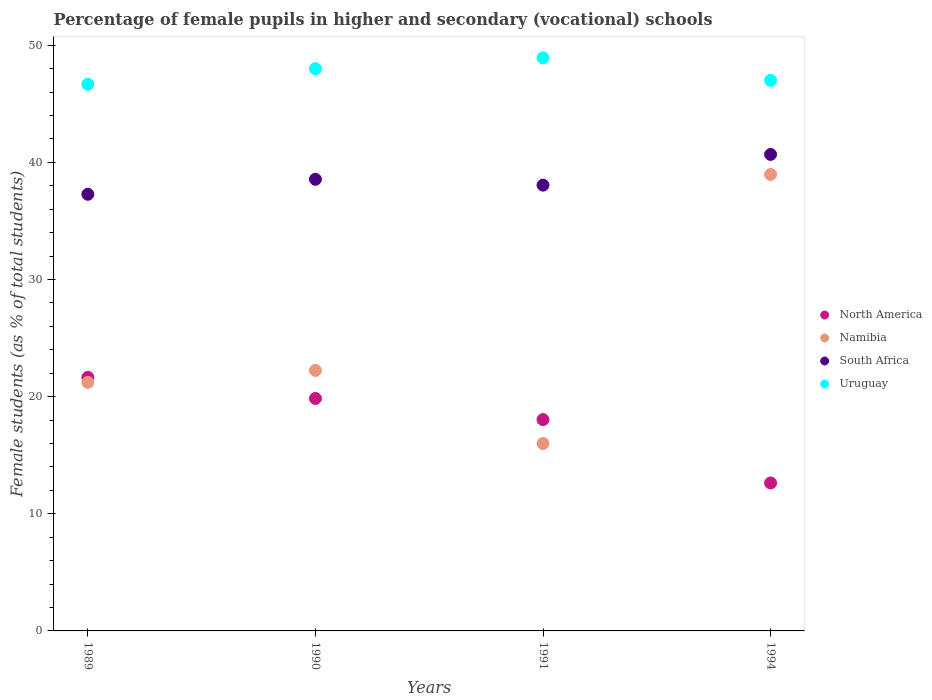Is the number of dotlines equal to the number of legend labels?
Offer a very short reply. Yes. What is the percentage of female pupils in higher and secondary schools in North America in 1994?
Make the answer very short. 12.63. Across all years, what is the maximum percentage of female pupils in higher and secondary schools in Namibia?
Your response must be concise. 38.97. Across all years, what is the minimum percentage of female pupils in higher and secondary schools in North America?
Your answer should be very brief. 12.63. In which year was the percentage of female pupils in higher and secondary schools in Namibia maximum?
Keep it short and to the point. 1994. In which year was the percentage of female pupils in higher and secondary schools in South Africa minimum?
Keep it short and to the point. 1989. What is the total percentage of female pupils in higher and secondary schools in North America in the graph?
Your answer should be very brief. 72.16. What is the difference between the percentage of female pupils in higher and secondary schools in North America in 1989 and that in 1991?
Offer a terse response. 3.61. What is the difference between the percentage of female pupils in higher and secondary schools in Uruguay in 1991 and the percentage of female pupils in higher and secondary schools in North America in 1990?
Offer a terse response. 29.08. What is the average percentage of female pupils in higher and secondary schools in North America per year?
Give a very brief answer. 18.04. In the year 1989, what is the difference between the percentage of female pupils in higher and secondary schools in Uruguay and percentage of female pupils in higher and secondary schools in Namibia?
Your answer should be compact. 25.45. In how many years, is the percentage of female pupils in higher and secondary schools in South Africa greater than 4 %?
Offer a terse response. 4. What is the ratio of the percentage of female pupils in higher and secondary schools in South Africa in 1990 to that in 1991?
Make the answer very short. 1.01. Is the percentage of female pupils in higher and secondary schools in Uruguay in 1991 less than that in 1994?
Provide a short and direct response. No. Is the difference between the percentage of female pupils in higher and secondary schools in Uruguay in 1989 and 1991 greater than the difference between the percentage of female pupils in higher and secondary schools in Namibia in 1989 and 1991?
Keep it short and to the point. No. What is the difference between the highest and the second highest percentage of female pupils in higher and secondary schools in Namibia?
Keep it short and to the point. 16.73. What is the difference between the highest and the lowest percentage of female pupils in higher and secondary schools in South Africa?
Your response must be concise. 3.4. Is it the case that in every year, the sum of the percentage of female pupils in higher and secondary schools in Uruguay and percentage of female pupils in higher and secondary schools in North America  is greater than the sum of percentage of female pupils in higher and secondary schools in South Africa and percentage of female pupils in higher and secondary schools in Namibia?
Give a very brief answer. Yes. Is the percentage of female pupils in higher and secondary schools in North America strictly greater than the percentage of female pupils in higher and secondary schools in Uruguay over the years?
Keep it short and to the point. No. Is the percentage of female pupils in higher and secondary schools in South Africa strictly less than the percentage of female pupils in higher and secondary schools in North America over the years?
Your answer should be very brief. No. How many dotlines are there?
Offer a very short reply. 4. Does the graph contain grids?
Offer a very short reply. No. How many legend labels are there?
Offer a terse response. 4. What is the title of the graph?
Offer a terse response. Percentage of female pupils in higher and secondary (vocational) schools. Does "New Caledonia" appear as one of the legend labels in the graph?
Your answer should be compact. No. What is the label or title of the Y-axis?
Ensure brevity in your answer.  Female students (as % of total students). What is the Female students (as % of total students) of North America in 1989?
Your answer should be very brief. 21.65. What is the Female students (as % of total students) in Namibia in 1989?
Your answer should be compact. 21.22. What is the Female students (as % of total students) in South Africa in 1989?
Offer a terse response. 37.28. What is the Female students (as % of total students) of Uruguay in 1989?
Provide a short and direct response. 46.67. What is the Female students (as % of total students) in North America in 1990?
Your answer should be very brief. 19.84. What is the Female students (as % of total students) in Namibia in 1990?
Make the answer very short. 22.24. What is the Female students (as % of total students) of South Africa in 1990?
Make the answer very short. 38.56. What is the Female students (as % of total students) of Uruguay in 1990?
Make the answer very short. 48. What is the Female students (as % of total students) of North America in 1991?
Keep it short and to the point. 18.04. What is the Female students (as % of total students) in Namibia in 1991?
Offer a terse response. 16. What is the Female students (as % of total students) of South Africa in 1991?
Ensure brevity in your answer.  38.06. What is the Female students (as % of total students) of Uruguay in 1991?
Provide a short and direct response. 48.93. What is the Female students (as % of total students) in North America in 1994?
Offer a terse response. 12.63. What is the Female students (as % of total students) of Namibia in 1994?
Offer a terse response. 38.97. What is the Female students (as % of total students) of South Africa in 1994?
Ensure brevity in your answer.  40.68. What is the Female students (as % of total students) in Uruguay in 1994?
Make the answer very short. 47.01. Across all years, what is the maximum Female students (as % of total students) of North America?
Provide a short and direct response. 21.65. Across all years, what is the maximum Female students (as % of total students) in Namibia?
Provide a succinct answer. 38.97. Across all years, what is the maximum Female students (as % of total students) in South Africa?
Keep it short and to the point. 40.68. Across all years, what is the maximum Female students (as % of total students) of Uruguay?
Offer a terse response. 48.93. Across all years, what is the minimum Female students (as % of total students) in North America?
Offer a terse response. 12.63. Across all years, what is the minimum Female students (as % of total students) of South Africa?
Your answer should be very brief. 37.28. Across all years, what is the minimum Female students (as % of total students) in Uruguay?
Keep it short and to the point. 46.67. What is the total Female students (as % of total students) in North America in the graph?
Your answer should be compact. 72.16. What is the total Female students (as % of total students) of Namibia in the graph?
Offer a very short reply. 98.43. What is the total Female students (as % of total students) in South Africa in the graph?
Your response must be concise. 154.57. What is the total Female students (as % of total students) of Uruguay in the graph?
Offer a terse response. 190.6. What is the difference between the Female students (as % of total students) of North America in 1989 and that in 1990?
Keep it short and to the point. 1.8. What is the difference between the Female students (as % of total students) of Namibia in 1989 and that in 1990?
Offer a terse response. -1.02. What is the difference between the Female students (as % of total students) in South Africa in 1989 and that in 1990?
Ensure brevity in your answer.  -1.28. What is the difference between the Female students (as % of total students) in Uruguay in 1989 and that in 1990?
Your response must be concise. -1.33. What is the difference between the Female students (as % of total students) of North America in 1989 and that in 1991?
Make the answer very short. 3.61. What is the difference between the Female students (as % of total students) of Namibia in 1989 and that in 1991?
Give a very brief answer. 5.22. What is the difference between the Female students (as % of total students) of South Africa in 1989 and that in 1991?
Your answer should be compact. -0.78. What is the difference between the Female students (as % of total students) of Uruguay in 1989 and that in 1991?
Ensure brevity in your answer.  -2.26. What is the difference between the Female students (as % of total students) in North America in 1989 and that in 1994?
Keep it short and to the point. 9.02. What is the difference between the Female students (as % of total students) of Namibia in 1989 and that in 1994?
Give a very brief answer. -17.75. What is the difference between the Female students (as % of total students) in South Africa in 1989 and that in 1994?
Offer a very short reply. -3.4. What is the difference between the Female students (as % of total students) in Uruguay in 1989 and that in 1994?
Keep it short and to the point. -0.34. What is the difference between the Female students (as % of total students) of North America in 1990 and that in 1991?
Provide a short and direct response. 1.8. What is the difference between the Female students (as % of total students) in Namibia in 1990 and that in 1991?
Offer a very short reply. 6.24. What is the difference between the Female students (as % of total students) in South Africa in 1990 and that in 1991?
Ensure brevity in your answer.  0.5. What is the difference between the Female students (as % of total students) in Uruguay in 1990 and that in 1991?
Offer a terse response. -0.93. What is the difference between the Female students (as % of total students) of North America in 1990 and that in 1994?
Your answer should be compact. 7.22. What is the difference between the Female students (as % of total students) of Namibia in 1990 and that in 1994?
Make the answer very short. -16.73. What is the difference between the Female students (as % of total students) in South Africa in 1990 and that in 1994?
Ensure brevity in your answer.  -2.13. What is the difference between the Female students (as % of total students) in North America in 1991 and that in 1994?
Keep it short and to the point. 5.41. What is the difference between the Female students (as % of total students) in Namibia in 1991 and that in 1994?
Give a very brief answer. -22.97. What is the difference between the Female students (as % of total students) in South Africa in 1991 and that in 1994?
Your answer should be compact. -2.62. What is the difference between the Female students (as % of total students) in Uruguay in 1991 and that in 1994?
Offer a very short reply. 1.92. What is the difference between the Female students (as % of total students) in North America in 1989 and the Female students (as % of total students) in Namibia in 1990?
Offer a very short reply. -0.59. What is the difference between the Female students (as % of total students) of North America in 1989 and the Female students (as % of total students) of South Africa in 1990?
Make the answer very short. -16.91. What is the difference between the Female students (as % of total students) of North America in 1989 and the Female students (as % of total students) of Uruguay in 1990?
Ensure brevity in your answer.  -26.35. What is the difference between the Female students (as % of total students) in Namibia in 1989 and the Female students (as % of total students) in South Africa in 1990?
Provide a short and direct response. -17.34. What is the difference between the Female students (as % of total students) of Namibia in 1989 and the Female students (as % of total students) of Uruguay in 1990?
Make the answer very short. -26.78. What is the difference between the Female students (as % of total students) in South Africa in 1989 and the Female students (as % of total students) in Uruguay in 1990?
Your answer should be very brief. -10.72. What is the difference between the Female students (as % of total students) in North America in 1989 and the Female students (as % of total students) in Namibia in 1991?
Offer a terse response. 5.65. What is the difference between the Female students (as % of total students) in North America in 1989 and the Female students (as % of total students) in South Africa in 1991?
Provide a succinct answer. -16.41. What is the difference between the Female students (as % of total students) in North America in 1989 and the Female students (as % of total students) in Uruguay in 1991?
Give a very brief answer. -27.28. What is the difference between the Female students (as % of total students) of Namibia in 1989 and the Female students (as % of total students) of South Africa in 1991?
Your answer should be compact. -16.84. What is the difference between the Female students (as % of total students) in Namibia in 1989 and the Female students (as % of total students) in Uruguay in 1991?
Your answer should be very brief. -27.71. What is the difference between the Female students (as % of total students) in South Africa in 1989 and the Female students (as % of total students) in Uruguay in 1991?
Make the answer very short. -11.65. What is the difference between the Female students (as % of total students) of North America in 1989 and the Female students (as % of total students) of Namibia in 1994?
Make the answer very short. -17.32. What is the difference between the Female students (as % of total students) in North America in 1989 and the Female students (as % of total students) in South Africa in 1994?
Provide a succinct answer. -19.03. What is the difference between the Female students (as % of total students) in North America in 1989 and the Female students (as % of total students) in Uruguay in 1994?
Offer a very short reply. -25.36. What is the difference between the Female students (as % of total students) of Namibia in 1989 and the Female students (as % of total students) of South Africa in 1994?
Offer a very short reply. -19.46. What is the difference between the Female students (as % of total students) of Namibia in 1989 and the Female students (as % of total students) of Uruguay in 1994?
Keep it short and to the point. -25.79. What is the difference between the Female students (as % of total students) in South Africa in 1989 and the Female students (as % of total students) in Uruguay in 1994?
Offer a terse response. -9.73. What is the difference between the Female students (as % of total students) of North America in 1990 and the Female students (as % of total students) of Namibia in 1991?
Your response must be concise. 3.84. What is the difference between the Female students (as % of total students) in North America in 1990 and the Female students (as % of total students) in South Africa in 1991?
Your response must be concise. -18.21. What is the difference between the Female students (as % of total students) of North America in 1990 and the Female students (as % of total students) of Uruguay in 1991?
Provide a short and direct response. -29.08. What is the difference between the Female students (as % of total students) of Namibia in 1990 and the Female students (as % of total students) of South Africa in 1991?
Ensure brevity in your answer.  -15.82. What is the difference between the Female students (as % of total students) in Namibia in 1990 and the Female students (as % of total students) in Uruguay in 1991?
Offer a very short reply. -26.69. What is the difference between the Female students (as % of total students) of South Africa in 1990 and the Female students (as % of total students) of Uruguay in 1991?
Offer a terse response. -10.37. What is the difference between the Female students (as % of total students) of North America in 1990 and the Female students (as % of total students) of Namibia in 1994?
Offer a terse response. -19.13. What is the difference between the Female students (as % of total students) of North America in 1990 and the Female students (as % of total students) of South Africa in 1994?
Make the answer very short. -20.84. What is the difference between the Female students (as % of total students) of North America in 1990 and the Female students (as % of total students) of Uruguay in 1994?
Your response must be concise. -27.16. What is the difference between the Female students (as % of total students) in Namibia in 1990 and the Female students (as % of total students) in South Africa in 1994?
Offer a very short reply. -18.44. What is the difference between the Female students (as % of total students) of Namibia in 1990 and the Female students (as % of total students) of Uruguay in 1994?
Offer a terse response. -24.77. What is the difference between the Female students (as % of total students) of South Africa in 1990 and the Female students (as % of total students) of Uruguay in 1994?
Provide a succinct answer. -8.45. What is the difference between the Female students (as % of total students) of North America in 1991 and the Female students (as % of total students) of Namibia in 1994?
Ensure brevity in your answer.  -20.93. What is the difference between the Female students (as % of total students) in North America in 1991 and the Female students (as % of total students) in South Africa in 1994?
Give a very brief answer. -22.64. What is the difference between the Female students (as % of total students) in North America in 1991 and the Female students (as % of total students) in Uruguay in 1994?
Ensure brevity in your answer.  -28.97. What is the difference between the Female students (as % of total students) of Namibia in 1991 and the Female students (as % of total students) of South Africa in 1994?
Offer a very short reply. -24.68. What is the difference between the Female students (as % of total students) in Namibia in 1991 and the Female students (as % of total students) in Uruguay in 1994?
Your answer should be compact. -31.01. What is the difference between the Female students (as % of total students) in South Africa in 1991 and the Female students (as % of total students) in Uruguay in 1994?
Make the answer very short. -8.95. What is the average Female students (as % of total students) in North America per year?
Your answer should be compact. 18.04. What is the average Female students (as % of total students) of Namibia per year?
Give a very brief answer. 24.61. What is the average Female students (as % of total students) of South Africa per year?
Offer a very short reply. 38.64. What is the average Female students (as % of total students) in Uruguay per year?
Make the answer very short. 47.65. In the year 1989, what is the difference between the Female students (as % of total students) of North America and Female students (as % of total students) of Namibia?
Your answer should be compact. 0.43. In the year 1989, what is the difference between the Female students (as % of total students) in North America and Female students (as % of total students) in South Africa?
Your response must be concise. -15.63. In the year 1989, what is the difference between the Female students (as % of total students) of North America and Female students (as % of total students) of Uruguay?
Your answer should be very brief. -25.02. In the year 1989, what is the difference between the Female students (as % of total students) of Namibia and Female students (as % of total students) of South Africa?
Your answer should be compact. -16.06. In the year 1989, what is the difference between the Female students (as % of total students) of Namibia and Female students (as % of total students) of Uruguay?
Offer a terse response. -25.45. In the year 1989, what is the difference between the Female students (as % of total students) of South Africa and Female students (as % of total students) of Uruguay?
Your answer should be compact. -9.39. In the year 1990, what is the difference between the Female students (as % of total students) of North America and Female students (as % of total students) of Namibia?
Your answer should be compact. -2.4. In the year 1990, what is the difference between the Female students (as % of total students) in North America and Female students (as % of total students) in South Africa?
Your answer should be very brief. -18.71. In the year 1990, what is the difference between the Female students (as % of total students) in North America and Female students (as % of total students) in Uruguay?
Offer a terse response. -28.15. In the year 1990, what is the difference between the Female students (as % of total students) of Namibia and Female students (as % of total students) of South Africa?
Provide a short and direct response. -16.31. In the year 1990, what is the difference between the Female students (as % of total students) in Namibia and Female students (as % of total students) in Uruguay?
Your response must be concise. -25.76. In the year 1990, what is the difference between the Female students (as % of total students) of South Africa and Female students (as % of total students) of Uruguay?
Offer a terse response. -9.44. In the year 1991, what is the difference between the Female students (as % of total students) of North America and Female students (as % of total students) of Namibia?
Offer a terse response. 2.04. In the year 1991, what is the difference between the Female students (as % of total students) in North America and Female students (as % of total students) in South Africa?
Make the answer very short. -20.02. In the year 1991, what is the difference between the Female students (as % of total students) in North America and Female students (as % of total students) in Uruguay?
Give a very brief answer. -30.89. In the year 1991, what is the difference between the Female students (as % of total students) of Namibia and Female students (as % of total students) of South Africa?
Give a very brief answer. -22.06. In the year 1991, what is the difference between the Female students (as % of total students) in Namibia and Female students (as % of total students) in Uruguay?
Your response must be concise. -32.93. In the year 1991, what is the difference between the Female students (as % of total students) of South Africa and Female students (as % of total students) of Uruguay?
Make the answer very short. -10.87. In the year 1994, what is the difference between the Female students (as % of total students) in North America and Female students (as % of total students) in Namibia?
Your answer should be very brief. -26.34. In the year 1994, what is the difference between the Female students (as % of total students) in North America and Female students (as % of total students) in South Africa?
Your answer should be very brief. -28.05. In the year 1994, what is the difference between the Female students (as % of total students) in North America and Female students (as % of total students) in Uruguay?
Ensure brevity in your answer.  -34.38. In the year 1994, what is the difference between the Female students (as % of total students) in Namibia and Female students (as % of total students) in South Africa?
Your response must be concise. -1.71. In the year 1994, what is the difference between the Female students (as % of total students) in Namibia and Female students (as % of total students) in Uruguay?
Your response must be concise. -8.04. In the year 1994, what is the difference between the Female students (as % of total students) in South Africa and Female students (as % of total students) in Uruguay?
Keep it short and to the point. -6.33. What is the ratio of the Female students (as % of total students) of Namibia in 1989 to that in 1990?
Your response must be concise. 0.95. What is the ratio of the Female students (as % of total students) of South Africa in 1989 to that in 1990?
Offer a terse response. 0.97. What is the ratio of the Female students (as % of total students) of Uruguay in 1989 to that in 1990?
Keep it short and to the point. 0.97. What is the ratio of the Female students (as % of total students) in North America in 1989 to that in 1991?
Provide a succinct answer. 1.2. What is the ratio of the Female students (as % of total students) of Namibia in 1989 to that in 1991?
Give a very brief answer. 1.33. What is the ratio of the Female students (as % of total students) in South Africa in 1989 to that in 1991?
Make the answer very short. 0.98. What is the ratio of the Female students (as % of total students) in Uruguay in 1989 to that in 1991?
Your response must be concise. 0.95. What is the ratio of the Female students (as % of total students) in North America in 1989 to that in 1994?
Give a very brief answer. 1.71. What is the ratio of the Female students (as % of total students) of Namibia in 1989 to that in 1994?
Provide a short and direct response. 0.54. What is the ratio of the Female students (as % of total students) of South Africa in 1989 to that in 1994?
Your answer should be compact. 0.92. What is the ratio of the Female students (as % of total students) in Uruguay in 1989 to that in 1994?
Make the answer very short. 0.99. What is the ratio of the Female students (as % of total students) in Namibia in 1990 to that in 1991?
Ensure brevity in your answer.  1.39. What is the ratio of the Female students (as % of total students) in South Africa in 1990 to that in 1991?
Offer a terse response. 1.01. What is the ratio of the Female students (as % of total students) of Uruguay in 1990 to that in 1991?
Ensure brevity in your answer.  0.98. What is the ratio of the Female students (as % of total students) in North America in 1990 to that in 1994?
Make the answer very short. 1.57. What is the ratio of the Female students (as % of total students) in Namibia in 1990 to that in 1994?
Provide a short and direct response. 0.57. What is the ratio of the Female students (as % of total students) in South Africa in 1990 to that in 1994?
Ensure brevity in your answer.  0.95. What is the ratio of the Female students (as % of total students) of Uruguay in 1990 to that in 1994?
Your response must be concise. 1.02. What is the ratio of the Female students (as % of total students) of North America in 1991 to that in 1994?
Ensure brevity in your answer.  1.43. What is the ratio of the Female students (as % of total students) of Namibia in 1991 to that in 1994?
Offer a very short reply. 0.41. What is the ratio of the Female students (as % of total students) in South Africa in 1991 to that in 1994?
Keep it short and to the point. 0.94. What is the ratio of the Female students (as % of total students) in Uruguay in 1991 to that in 1994?
Provide a succinct answer. 1.04. What is the difference between the highest and the second highest Female students (as % of total students) in North America?
Your answer should be very brief. 1.8. What is the difference between the highest and the second highest Female students (as % of total students) in Namibia?
Ensure brevity in your answer.  16.73. What is the difference between the highest and the second highest Female students (as % of total students) of South Africa?
Provide a short and direct response. 2.13. What is the difference between the highest and the second highest Female students (as % of total students) of Uruguay?
Provide a succinct answer. 0.93. What is the difference between the highest and the lowest Female students (as % of total students) of North America?
Your answer should be very brief. 9.02. What is the difference between the highest and the lowest Female students (as % of total students) in Namibia?
Ensure brevity in your answer.  22.97. What is the difference between the highest and the lowest Female students (as % of total students) of South Africa?
Provide a succinct answer. 3.4. What is the difference between the highest and the lowest Female students (as % of total students) in Uruguay?
Keep it short and to the point. 2.26. 